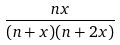<formula> <loc_0><loc_0><loc_500><loc_500>\frac { n x } { ( n + x ) ( n + 2 x ) }</formula> 